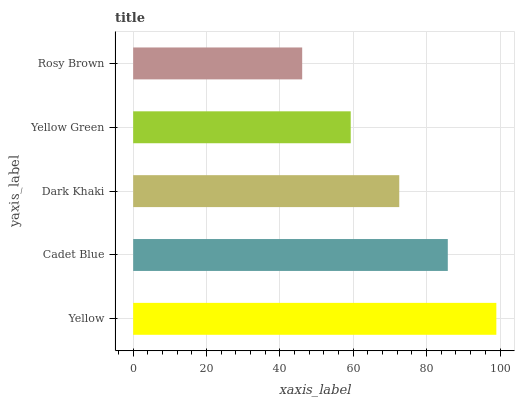Is Rosy Brown the minimum?
Answer yes or no. Yes. Is Yellow the maximum?
Answer yes or no. Yes. Is Cadet Blue the minimum?
Answer yes or no. No. Is Cadet Blue the maximum?
Answer yes or no. No. Is Yellow greater than Cadet Blue?
Answer yes or no. Yes. Is Cadet Blue less than Yellow?
Answer yes or no. Yes. Is Cadet Blue greater than Yellow?
Answer yes or no. No. Is Yellow less than Cadet Blue?
Answer yes or no. No. Is Dark Khaki the high median?
Answer yes or no. Yes. Is Dark Khaki the low median?
Answer yes or no. Yes. Is Cadet Blue the high median?
Answer yes or no. No. Is Rosy Brown the low median?
Answer yes or no. No. 